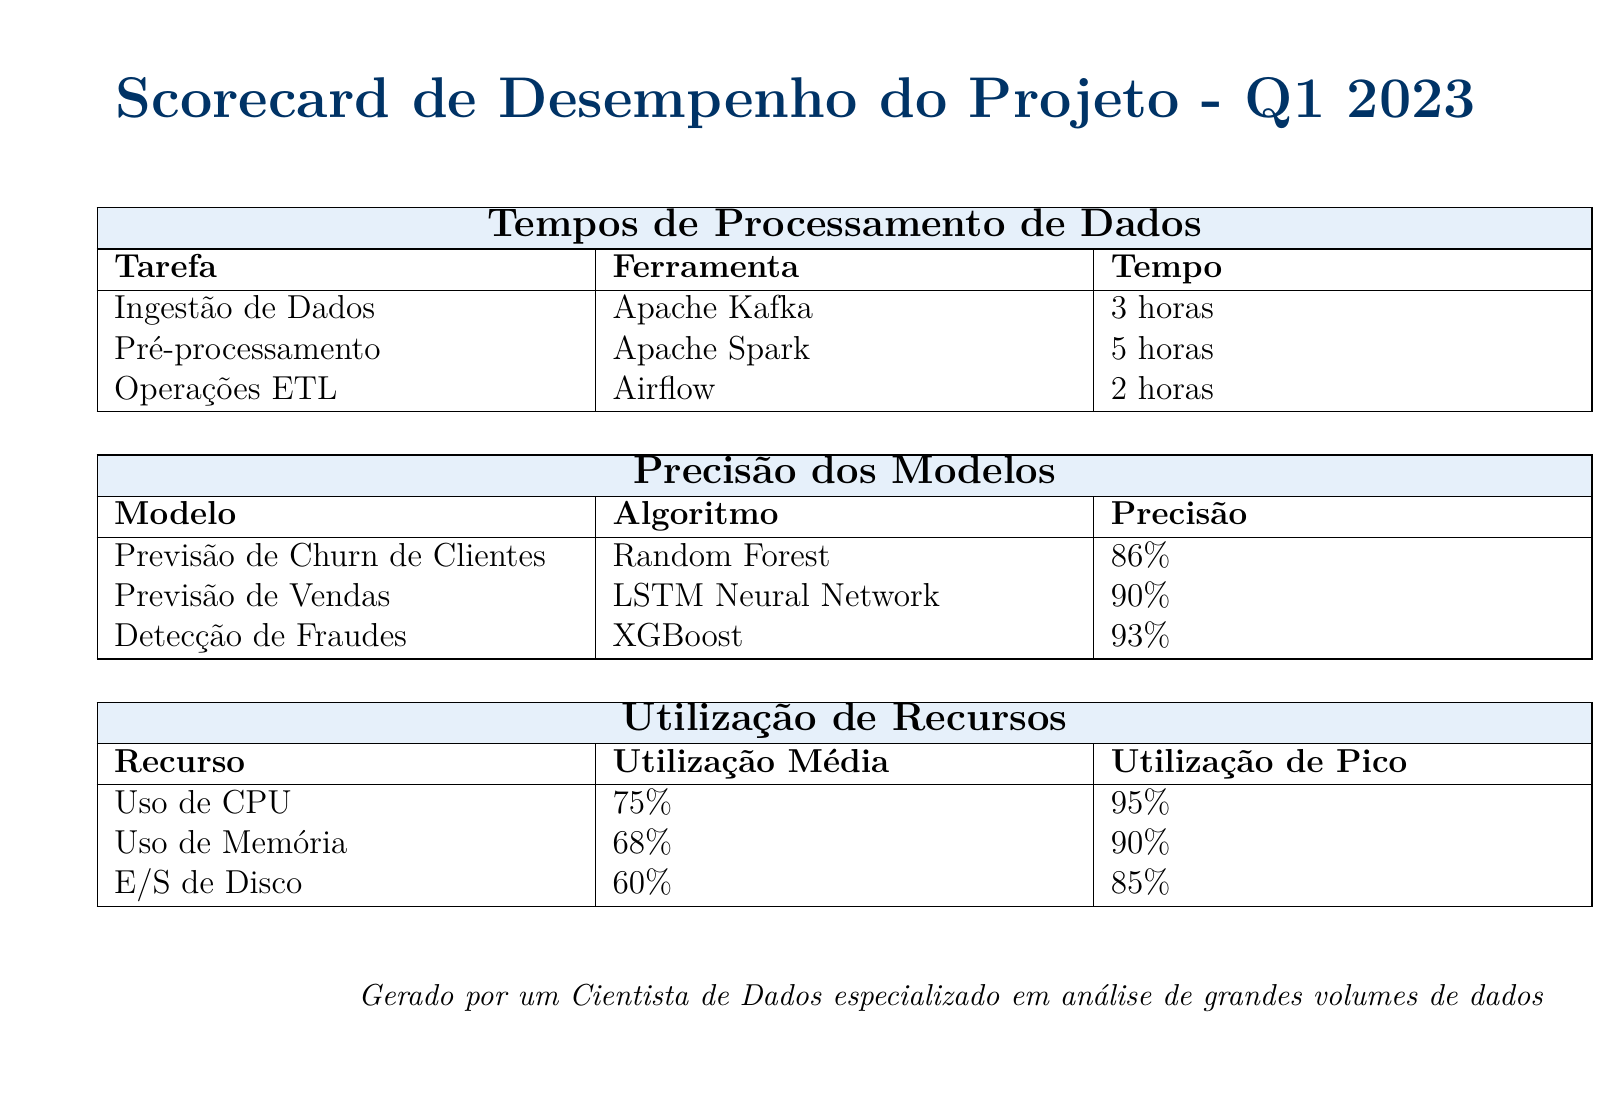Qual é o tempo de ingestão de dados? O tempo de ingestão de dados é especificado na tabela de tempos de processamento de dados.
Answer: 3 horas Qual é a precisão do modelo de detecção de fraudes? A precisão do modelo de detecção de fraudes é indicada na tabela de precisão dos modelos.
Answer: 93% Qual foi a utilização média de CPU? A utilização média de CPU é apresentada na tabela de utilização de recursos.
Answer: 75% Qual ferramenta foi utilizada para o pré-processamento? A ferramenta utilizada para o pré-processamento é mencionada na tabela de tempos de processamento de dados.
Answer: Apache Spark Qual é o tempo total de processamento, somando ingestão, pré-processamento e ETL? O tempo total é a soma dos tempos de cada tarefa listada na tabela de tempos de processamento de dados.
Answer: 10 horas Qual é o modelo com a maior precisão? O modelo com a maior precisão pode ser encontrado na tabela de precisão dos modelos, que lista todos os modelos e suas precisões.
Answer: Detecção de Fraudes Qual foi a utilização de pico de memória? A utilização de pico de memória está indicada na tabela de utilização de recursos.
Answer: 90% Quantas horas levou o processamento ETL? O tempo de processamento ETL é listado na tabela de tempos de processamento de dados.
Answer: 2 horas Qual algoritmo foi usado na previsão de vendas? O algoritmo usado na previsão de vendas é especificado na tabela de precisão dos modelos.
Answer: LSTM Neural Network 